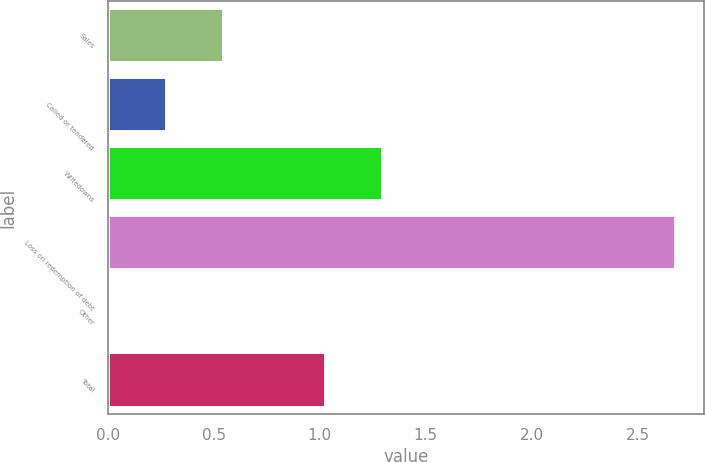Convert chart. <chart><loc_0><loc_0><loc_500><loc_500><bar_chart><fcel>Sales<fcel>Called or tendered<fcel>Writedowns<fcel>Loss on redemption of debt<fcel>Other<fcel>Total<nl><fcel>0.55<fcel>0.28<fcel>1.3<fcel>2.68<fcel>0.01<fcel>1.03<nl></chart> 